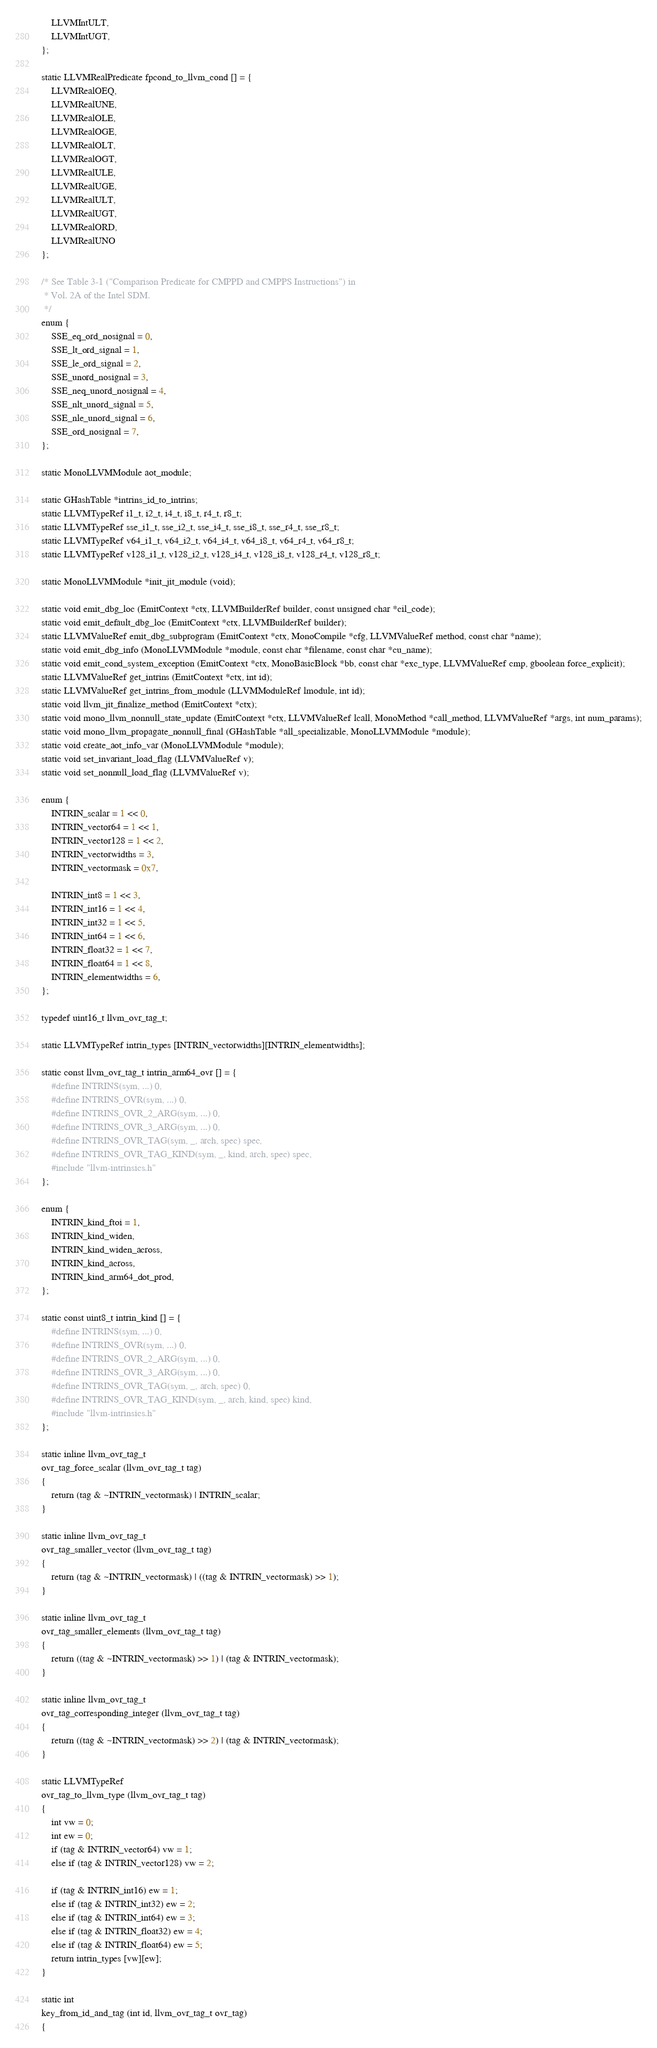<code> <loc_0><loc_0><loc_500><loc_500><_C_>	LLVMIntULT,
	LLVMIntUGT,
};

static LLVMRealPredicate fpcond_to_llvm_cond [] = {
	LLVMRealOEQ,
	LLVMRealUNE,
	LLVMRealOLE,
	LLVMRealOGE,
	LLVMRealOLT,
	LLVMRealOGT,
	LLVMRealULE,
	LLVMRealUGE,
	LLVMRealULT,
	LLVMRealUGT,
	LLVMRealORD,
	LLVMRealUNO
};

/* See Table 3-1 ("Comparison Predicate for CMPPD and CMPPS Instructions") in
 * Vol. 2A of the Intel SDM.
 */
enum {
    SSE_eq_ord_nosignal = 0,
    SSE_lt_ord_signal = 1,
    SSE_le_ord_signal = 2,
    SSE_unord_nosignal = 3,
    SSE_neq_unord_nosignal = 4,
    SSE_nlt_unord_signal = 5,
    SSE_nle_unord_signal = 6,
    SSE_ord_nosignal = 7,
};

static MonoLLVMModule aot_module;

static GHashTable *intrins_id_to_intrins;
static LLVMTypeRef i1_t, i2_t, i4_t, i8_t, r4_t, r8_t;
static LLVMTypeRef sse_i1_t, sse_i2_t, sse_i4_t, sse_i8_t, sse_r4_t, sse_r8_t;
static LLVMTypeRef v64_i1_t, v64_i2_t, v64_i4_t, v64_i8_t, v64_r4_t, v64_r8_t;
static LLVMTypeRef v128_i1_t, v128_i2_t, v128_i4_t, v128_i8_t, v128_r4_t, v128_r8_t;

static MonoLLVMModule *init_jit_module (void);

static void emit_dbg_loc (EmitContext *ctx, LLVMBuilderRef builder, const unsigned char *cil_code);
static void emit_default_dbg_loc (EmitContext *ctx, LLVMBuilderRef builder);
static LLVMValueRef emit_dbg_subprogram (EmitContext *ctx, MonoCompile *cfg, LLVMValueRef method, const char *name);
static void emit_dbg_info (MonoLLVMModule *module, const char *filename, const char *cu_name);
static void emit_cond_system_exception (EmitContext *ctx, MonoBasicBlock *bb, const char *exc_type, LLVMValueRef cmp, gboolean force_explicit);
static LLVMValueRef get_intrins (EmitContext *ctx, int id);
static LLVMValueRef get_intrins_from_module (LLVMModuleRef lmodule, int id);
static void llvm_jit_finalize_method (EmitContext *ctx);
static void mono_llvm_nonnull_state_update (EmitContext *ctx, LLVMValueRef lcall, MonoMethod *call_method, LLVMValueRef *args, int num_params);
static void mono_llvm_propagate_nonnull_final (GHashTable *all_specializable, MonoLLVMModule *module);
static void create_aot_info_var (MonoLLVMModule *module);
static void set_invariant_load_flag (LLVMValueRef v);
static void set_nonnull_load_flag (LLVMValueRef v);

enum {
	INTRIN_scalar = 1 << 0,
	INTRIN_vector64 = 1 << 1,
	INTRIN_vector128 = 1 << 2,
	INTRIN_vectorwidths = 3,
	INTRIN_vectormask = 0x7,

	INTRIN_int8 = 1 << 3,
	INTRIN_int16 = 1 << 4,
	INTRIN_int32 = 1 << 5,
	INTRIN_int64 = 1 << 6,
	INTRIN_float32 = 1 << 7,
	INTRIN_float64 = 1 << 8,
	INTRIN_elementwidths = 6,
};

typedef uint16_t llvm_ovr_tag_t;

static LLVMTypeRef intrin_types [INTRIN_vectorwidths][INTRIN_elementwidths];

static const llvm_ovr_tag_t intrin_arm64_ovr [] = {
	#define INTRINS(sym, ...) 0,
	#define INTRINS_OVR(sym, ...) 0,
	#define INTRINS_OVR_2_ARG(sym, ...) 0,
	#define INTRINS_OVR_3_ARG(sym, ...) 0,
	#define INTRINS_OVR_TAG(sym, _, arch, spec) spec,
	#define INTRINS_OVR_TAG_KIND(sym, _, kind, arch, spec) spec,
	#include "llvm-intrinsics.h"
};

enum {
	INTRIN_kind_ftoi = 1,
	INTRIN_kind_widen,
	INTRIN_kind_widen_across,
	INTRIN_kind_across,
	INTRIN_kind_arm64_dot_prod,
};

static const uint8_t intrin_kind [] = {
	#define INTRINS(sym, ...) 0,
	#define INTRINS_OVR(sym, ...) 0,
	#define INTRINS_OVR_2_ARG(sym, ...) 0,
	#define INTRINS_OVR_3_ARG(sym, ...) 0,
	#define INTRINS_OVR_TAG(sym, _, arch, spec) 0,
	#define INTRINS_OVR_TAG_KIND(sym, _, arch, kind, spec) kind,
	#include "llvm-intrinsics.h"
};

static inline llvm_ovr_tag_t
ovr_tag_force_scalar (llvm_ovr_tag_t tag)
{
	return (tag & ~INTRIN_vectormask) | INTRIN_scalar;
}

static inline llvm_ovr_tag_t
ovr_tag_smaller_vector (llvm_ovr_tag_t tag)
{
	return (tag & ~INTRIN_vectormask) | ((tag & INTRIN_vectormask) >> 1);
}

static inline llvm_ovr_tag_t
ovr_tag_smaller_elements (llvm_ovr_tag_t tag)
{
	return ((tag & ~INTRIN_vectormask) >> 1) | (tag & INTRIN_vectormask);
}

static inline llvm_ovr_tag_t
ovr_tag_corresponding_integer (llvm_ovr_tag_t tag)
{
	return ((tag & ~INTRIN_vectormask) >> 2) | (tag & INTRIN_vectormask);
}

static LLVMTypeRef
ovr_tag_to_llvm_type (llvm_ovr_tag_t tag)
{
	int vw = 0;
	int ew = 0;
	if (tag & INTRIN_vector64) vw = 1;
	else if (tag & INTRIN_vector128) vw = 2;

	if (tag & INTRIN_int16) ew = 1;
	else if (tag & INTRIN_int32) ew = 2;
	else if (tag & INTRIN_int64) ew = 3;
	else if (tag & INTRIN_float32) ew = 4;
	else if (tag & INTRIN_float64) ew = 5;
	return intrin_types [vw][ew];
}

static int
key_from_id_and_tag (int id, llvm_ovr_tag_t ovr_tag)
{</code> 